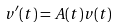Convert formula to latex. <formula><loc_0><loc_0><loc_500><loc_500>v ^ { \prime } ( t ) = A ( t ) v ( t )</formula> 